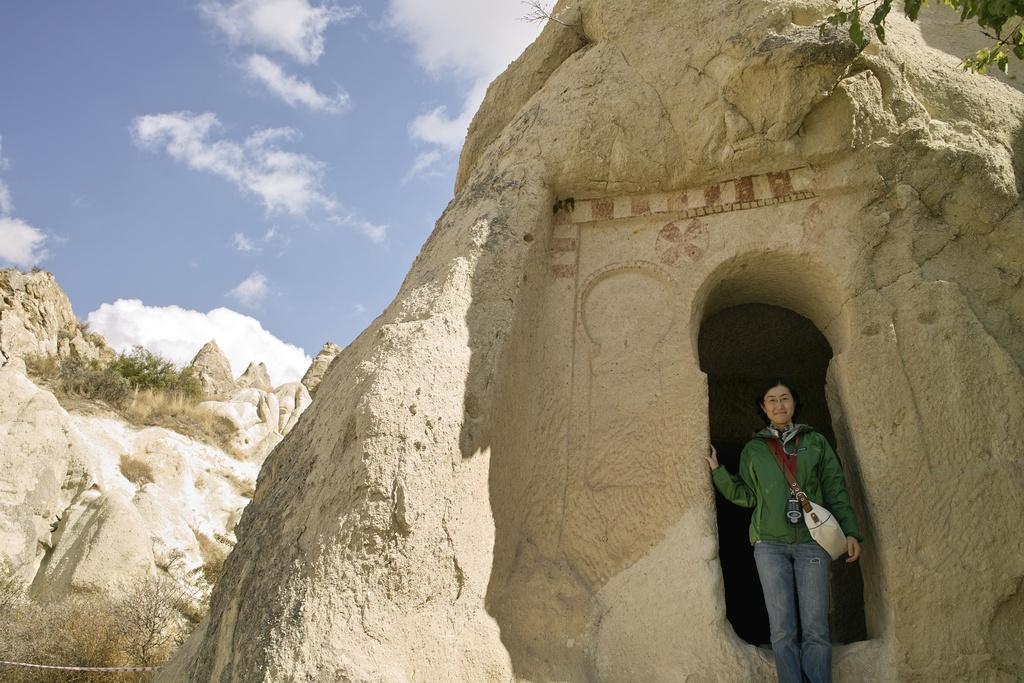In one or two sentences, can you explain what this image depicts? In this picture I can see a woman standing on the right side, it looks like a cave. In the background I can see the trees, stones. At the top there is the sky. 